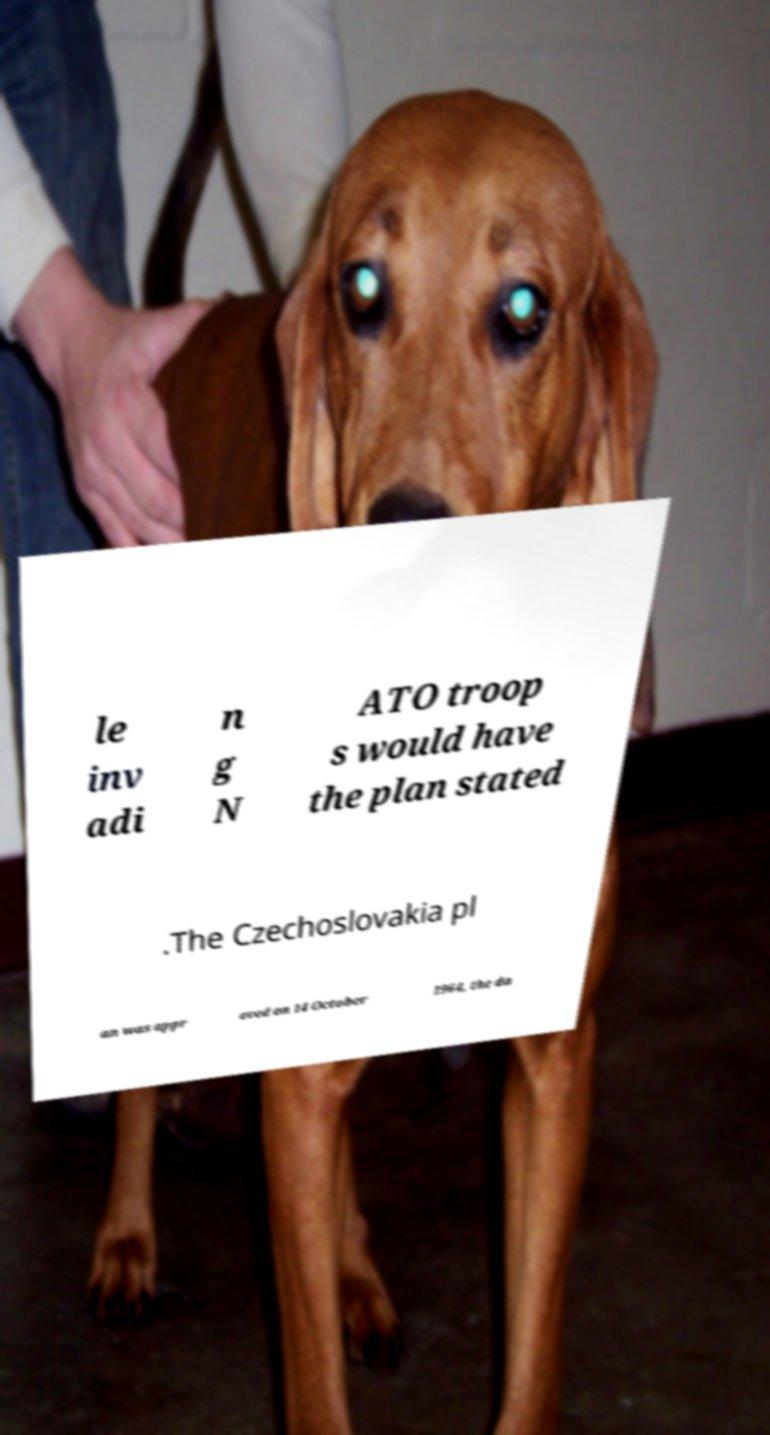Could you assist in decoding the text presented in this image and type it out clearly? le inv adi n g N ATO troop s would have the plan stated .The Czechoslovakia pl an was appr oved on 14 October 1964, the da 